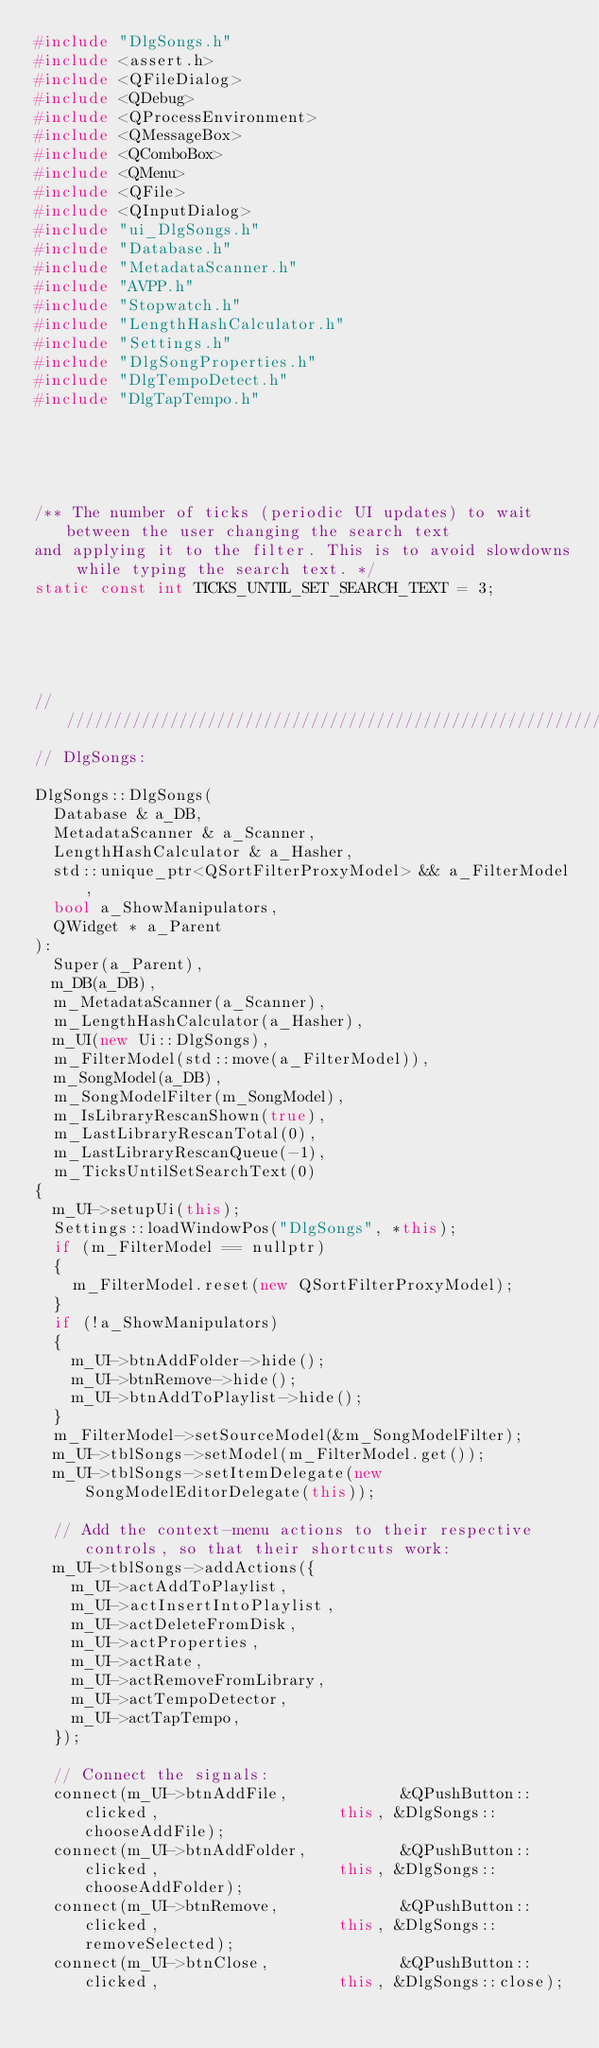Convert code to text. <code><loc_0><loc_0><loc_500><loc_500><_C++_>#include "DlgSongs.h"
#include <assert.h>
#include <QFileDialog>
#include <QDebug>
#include <QProcessEnvironment>
#include <QMessageBox>
#include <QComboBox>
#include <QMenu>
#include <QFile>
#include <QInputDialog>
#include "ui_DlgSongs.h"
#include "Database.h"
#include "MetadataScanner.h"
#include "AVPP.h"
#include "Stopwatch.h"
#include "LengthHashCalculator.h"
#include "Settings.h"
#include "DlgSongProperties.h"
#include "DlgTempoDetect.h"
#include "DlgTapTempo.h"





/** The number of ticks (periodic UI updates) to wait between the user changing the search text
and applying it to the filter. This is to avoid slowdowns while typing the search text. */
static const int TICKS_UNTIL_SET_SEARCH_TEXT = 3;





////////////////////////////////////////////////////////////////////////////////
// DlgSongs:

DlgSongs::DlgSongs(
	Database & a_DB,
	MetadataScanner & a_Scanner,
	LengthHashCalculator & a_Hasher,
	std::unique_ptr<QSortFilterProxyModel> && a_FilterModel,
	bool a_ShowManipulators,
	QWidget * a_Parent
):
	Super(a_Parent),
	m_DB(a_DB),
	m_MetadataScanner(a_Scanner),
	m_LengthHashCalculator(a_Hasher),
	m_UI(new Ui::DlgSongs),
	m_FilterModel(std::move(a_FilterModel)),
	m_SongModel(a_DB),
	m_SongModelFilter(m_SongModel),
	m_IsLibraryRescanShown(true),
	m_LastLibraryRescanTotal(0),
	m_LastLibraryRescanQueue(-1),
	m_TicksUntilSetSearchText(0)
{
	m_UI->setupUi(this);
	Settings::loadWindowPos("DlgSongs", *this);
	if (m_FilterModel == nullptr)
	{
		m_FilterModel.reset(new QSortFilterProxyModel);
	}
	if (!a_ShowManipulators)
	{
		m_UI->btnAddFolder->hide();
		m_UI->btnRemove->hide();
		m_UI->btnAddToPlaylist->hide();
	}
	m_FilterModel->setSourceModel(&m_SongModelFilter);
	m_UI->tblSongs->setModel(m_FilterModel.get());
	m_UI->tblSongs->setItemDelegate(new SongModelEditorDelegate(this));

	// Add the context-menu actions to their respective controls, so that their shortcuts work:
	m_UI->tblSongs->addActions({
		m_UI->actAddToPlaylist,
		m_UI->actInsertIntoPlaylist,
		m_UI->actDeleteFromDisk,
		m_UI->actProperties,
		m_UI->actRate,
		m_UI->actRemoveFromLibrary,
		m_UI->actTempoDetector,
		m_UI->actTapTempo,
	});

	// Connect the signals:
	connect(m_UI->btnAddFile,            &QPushButton::clicked,                   this, &DlgSongs::chooseAddFile);
	connect(m_UI->btnAddFolder,          &QPushButton::clicked,                   this, &DlgSongs::chooseAddFolder);
	connect(m_UI->btnRemove,             &QPushButton::clicked,                   this, &DlgSongs::removeSelected);
	connect(m_UI->btnClose,              &QPushButton::clicked,                   this, &DlgSongs::close);</code> 